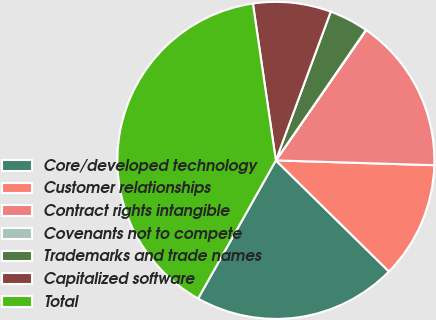Convert chart to OTSL. <chart><loc_0><loc_0><loc_500><loc_500><pie_chart><fcel>Core/developed technology<fcel>Customer relationships<fcel>Contract rights intangible<fcel>Covenants not to compete<fcel>Trademarks and trade names<fcel>Capitalized software<fcel>Total<nl><fcel>20.8%<fcel>11.88%<fcel>15.83%<fcel>0.04%<fcel>3.99%<fcel>7.94%<fcel>39.53%<nl></chart> 